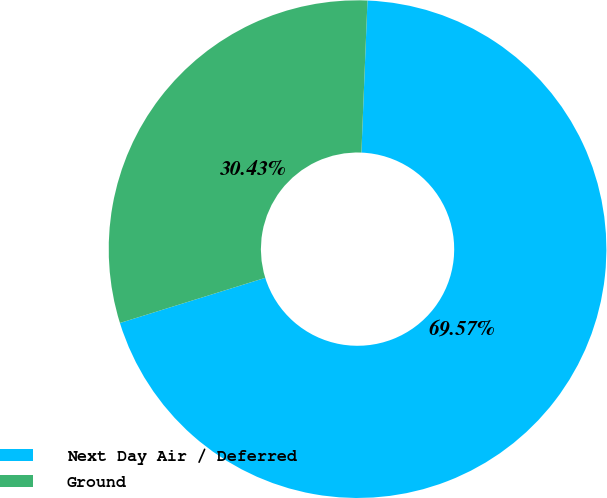Convert chart to OTSL. <chart><loc_0><loc_0><loc_500><loc_500><pie_chart><fcel>Next Day Air / Deferred<fcel>Ground<nl><fcel>69.57%<fcel>30.43%<nl></chart> 